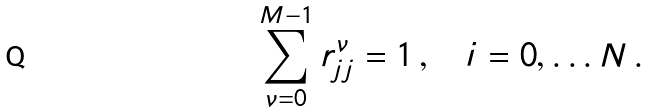Convert formula to latex. <formula><loc_0><loc_0><loc_500><loc_500>\sum _ { \nu = 0 } ^ { M - 1 } r _ { j j } ^ { \nu } = 1 \, , \quad i = 0 , \dots N \, .</formula> 